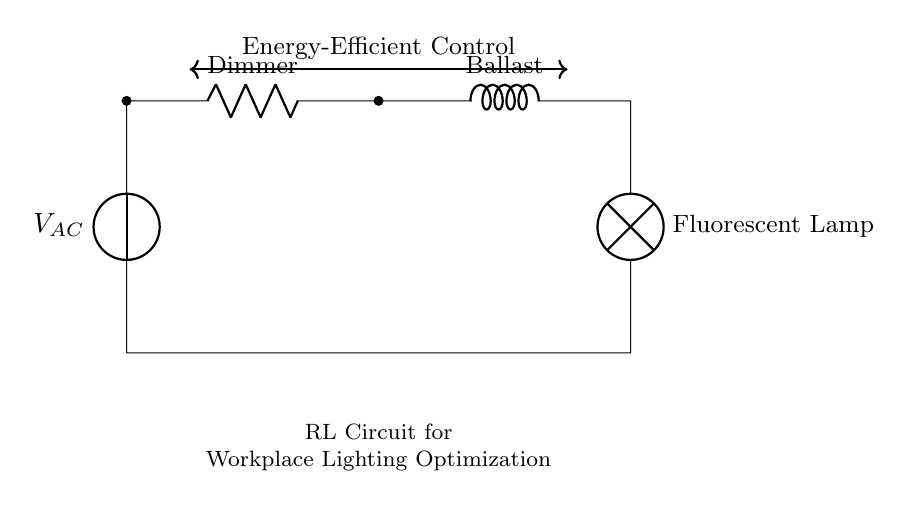What is the main power source in the circuit? The main power source indicated in the circuit is a voltage source labeled as V_AC, which supplies the alternating voltage to the connected components.
Answer: V_AC What component provides variable resistance in this circuit? The component providing variable resistance is labeled as Dimmer, which allows for adjustment of the current flow to the circuit based on desired lighting levels.
Answer: Dimmer What is the function of the ballast in this circuit? The ballast is used to control and limit the current to the Fluorescent Lamp, ensuring it operates efficiently and prevents excessive current that could lead to failure.
Answer: Control current How do the resistor and inductor work together in this lighting circuit? In this lighting circuit, the resistor (Dimmer) and inductor (Ballast) work together to manage the electrical current flowing to the fluorescent lamp, improving energy efficiency and performance by combining resistive and inductive properties.
Answer: Enhance efficiency What type of circuit is represented here? This circuit is a Resistor-Inductor (RL) circuit, which combines a resistor and an inductor to achieve particular electrical characteristics advantageous for lighting control.
Answer: Resistor-Inductor What does the arrow connecting the components indicate? The arrow indicates a two-way connection that signifies the electrical continuity between the components, allowing current to flow between the voltage source, dimmer, ballast, and lamp.
Answer: Continuity What type of lamp is used in this circuit? The lamp used in this circuit is specified as a Fluorescent Lamp, known for its energy efficiency compared to traditional incandescent lamps.
Answer: Fluorescent Lamp 